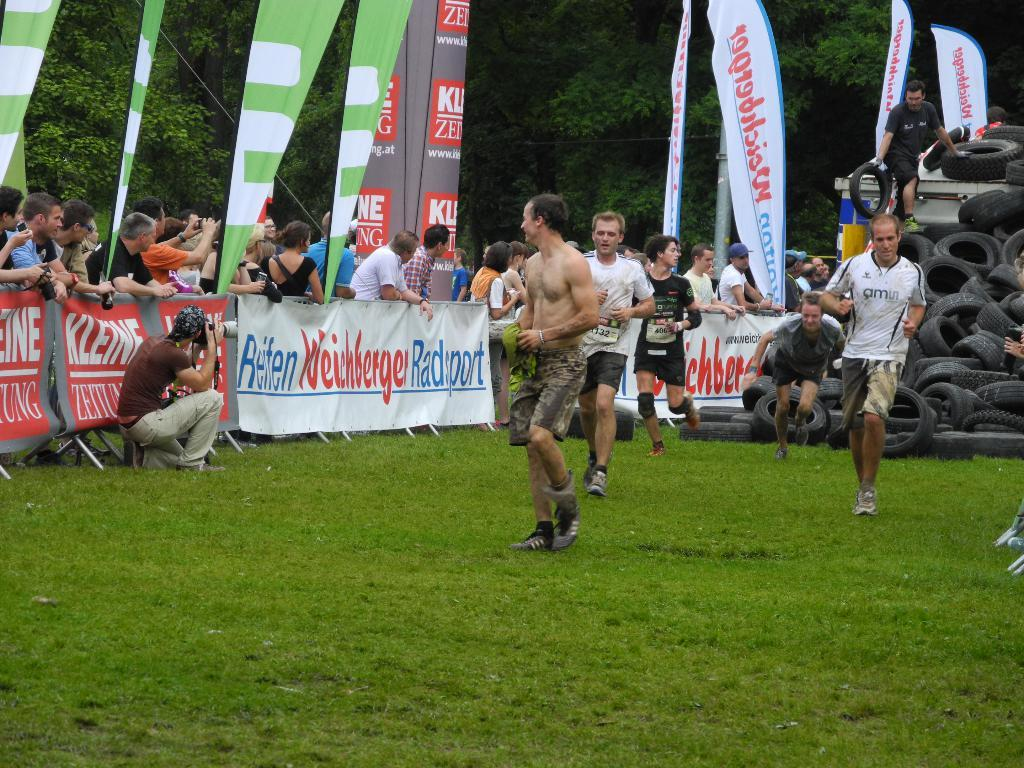<image>
Offer a succinct explanation of the picture presented. Players participating in an athletic competition with a banner on the wall that reads Reten Weinberger Radsport. 